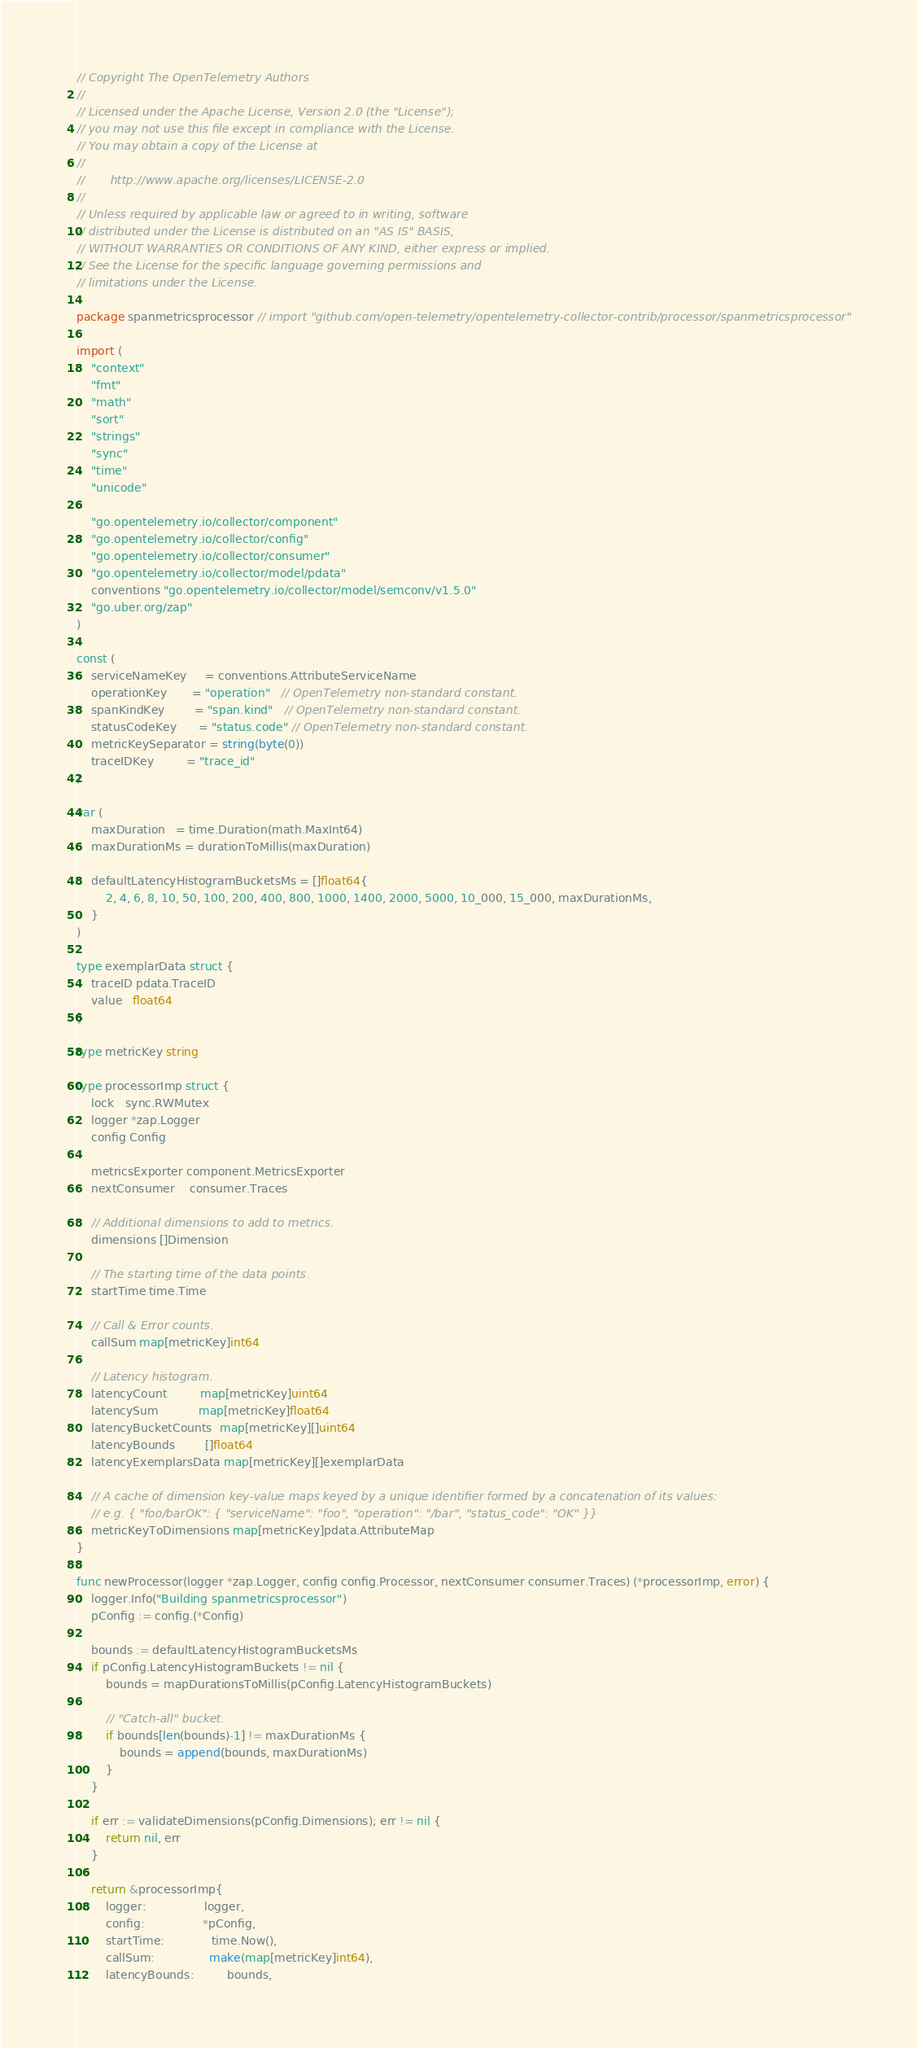<code> <loc_0><loc_0><loc_500><loc_500><_Go_>// Copyright The OpenTelemetry Authors
//
// Licensed under the Apache License, Version 2.0 (the "License");
// you may not use this file except in compliance with the License.
// You may obtain a copy of the License at
//
//       http://www.apache.org/licenses/LICENSE-2.0
//
// Unless required by applicable law or agreed to in writing, software
// distributed under the License is distributed on an "AS IS" BASIS,
// WITHOUT WARRANTIES OR CONDITIONS OF ANY KIND, either express or implied.
// See the License for the specific language governing permissions and
// limitations under the License.

package spanmetricsprocessor // import "github.com/open-telemetry/opentelemetry-collector-contrib/processor/spanmetricsprocessor"

import (
	"context"
	"fmt"
	"math"
	"sort"
	"strings"
	"sync"
	"time"
	"unicode"

	"go.opentelemetry.io/collector/component"
	"go.opentelemetry.io/collector/config"
	"go.opentelemetry.io/collector/consumer"
	"go.opentelemetry.io/collector/model/pdata"
	conventions "go.opentelemetry.io/collector/model/semconv/v1.5.0"
	"go.uber.org/zap"
)

const (
	serviceNameKey     = conventions.AttributeServiceName
	operationKey       = "operation"   // OpenTelemetry non-standard constant.
	spanKindKey        = "span.kind"   // OpenTelemetry non-standard constant.
	statusCodeKey      = "status.code" // OpenTelemetry non-standard constant.
	metricKeySeparator = string(byte(0))
	traceIDKey         = "trace_id"
)

var (
	maxDuration   = time.Duration(math.MaxInt64)
	maxDurationMs = durationToMillis(maxDuration)

	defaultLatencyHistogramBucketsMs = []float64{
		2, 4, 6, 8, 10, 50, 100, 200, 400, 800, 1000, 1400, 2000, 5000, 10_000, 15_000, maxDurationMs,
	}
)

type exemplarData struct {
	traceID pdata.TraceID
	value   float64
}

type metricKey string

type processorImp struct {
	lock   sync.RWMutex
	logger *zap.Logger
	config Config

	metricsExporter component.MetricsExporter
	nextConsumer    consumer.Traces

	// Additional dimensions to add to metrics.
	dimensions []Dimension

	// The starting time of the data points.
	startTime time.Time

	// Call & Error counts.
	callSum map[metricKey]int64

	// Latency histogram.
	latencyCount         map[metricKey]uint64
	latencySum           map[metricKey]float64
	latencyBucketCounts  map[metricKey][]uint64
	latencyBounds        []float64
	latencyExemplarsData map[metricKey][]exemplarData

	// A cache of dimension key-value maps keyed by a unique identifier formed by a concatenation of its values:
	// e.g. { "foo/barOK": { "serviceName": "foo", "operation": "/bar", "status_code": "OK" }}
	metricKeyToDimensions map[metricKey]pdata.AttributeMap
}

func newProcessor(logger *zap.Logger, config config.Processor, nextConsumer consumer.Traces) (*processorImp, error) {
	logger.Info("Building spanmetricsprocessor")
	pConfig := config.(*Config)

	bounds := defaultLatencyHistogramBucketsMs
	if pConfig.LatencyHistogramBuckets != nil {
		bounds = mapDurationsToMillis(pConfig.LatencyHistogramBuckets)

		// "Catch-all" bucket.
		if bounds[len(bounds)-1] != maxDurationMs {
			bounds = append(bounds, maxDurationMs)
		}
	}

	if err := validateDimensions(pConfig.Dimensions); err != nil {
		return nil, err
	}

	return &processorImp{
		logger:                logger,
		config:                *pConfig,
		startTime:             time.Now(),
		callSum:               make(map[metricKey]int64),
		latencyBounds:         bounds,</code> 